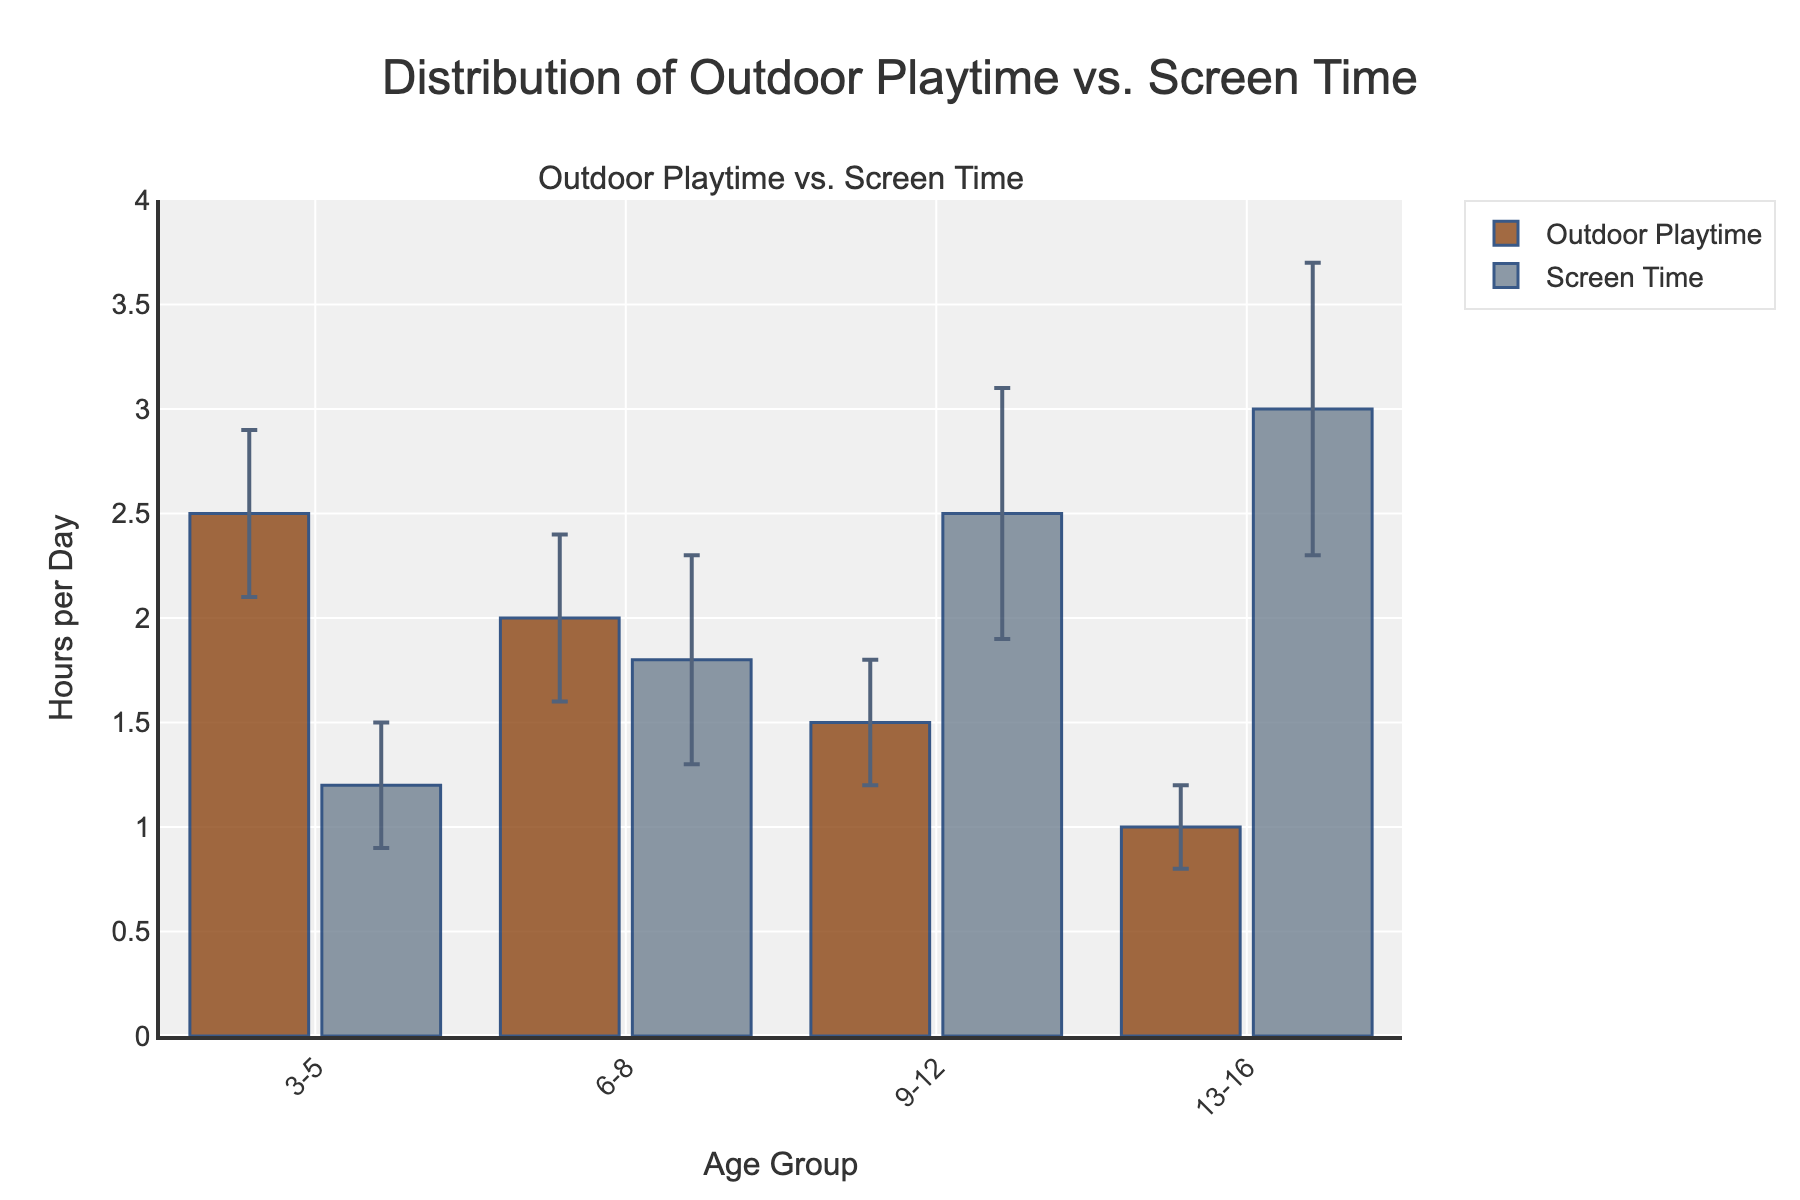What is the title of the figure? The title is usually found at the top of the figure. It describes what the chart is about. In this case, it says "Distribution of Outdoor Playtime vs. Screen Time".
Answer: Distribution of Outdoor Playtime vs. Screen Time Which age group has the highest mean screen time? By comparing the heights of the bars labeled "Screen Time" across different age groups, the tallest bar corresponds to the age group 13-16.
Answer: 13-16 What is the mean outdoor playtime for the age group 9-12? Look at the bar labeled "Outdoor Playtime" for the age group 9-12. The height of this bar represents the mean outdoor playtime hours.
Answer: 1.5 hours For the age group 6-8, how does mean screen time compare to mean outdoor playtime? Compare the heights of the "Screen Time" and "Outdoor Playtime" bars for the age group 6-8. The screen time bar is slightly shorter, indicating less screen time compared to outdoor playtime.
Answer: Less than outdoor playtime Which category shows most variation in error bars for age group 13-16? Look at the error bars for both categories for age group 13-16. The "Screen Time" category has longer error bars, indicating greater variation.
Answer: Screen Time What is the difference in mean screen time between age groups 3-5 and 13-16? Check the heights of the "Screen Time" bars for age groups 3-5 and 13-16. Subtract the mean for 3-5 from the mean for 13-16. 3.0 - 1.2 equals to 1.8 hours.
Answer: 1.8 hours Does outdoor playtime decrease or increase with age? Observe the trend in the heights of the bars labeled "Outdoor Playtime" across different age groups. The heights decrease as age increases.
Answer: Decrease What is the combined mean outdoor playtime for all age groups? Add the mean outdoor playtime hours for all age groups: 2.5 + 2.0 + 1.5 + 1.0 equals to 7.0 hours.
Answer: 7.0 hours How does the standard error range for screen time in age group 9-12 compare to its mean? The error bar for screen time in age group 9-12 extends from 2.5 - 0.6 to 2.5 + 0.6, which means it ranges from 1.9 to 3.1. This is approximately 24% of the value.
Answer: 24% 